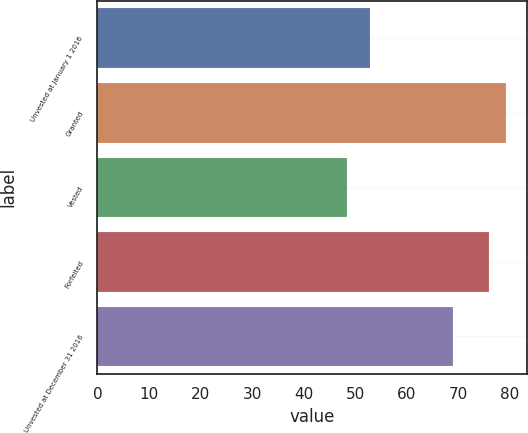Convert chart to OTSL. <chart><loc_0><loc_0><loc_500><loc_500><bar_chart><fcel>Unvested at January 1 2016<fcel>Granted<fcel>Vested<fcel>Forfeited<fcel>Unvested at December 31 2016<nl><fcel>52.9<fcel>79.27<fcel>48.38<fcel>76.01<fcel>68.98<nl></chart> 